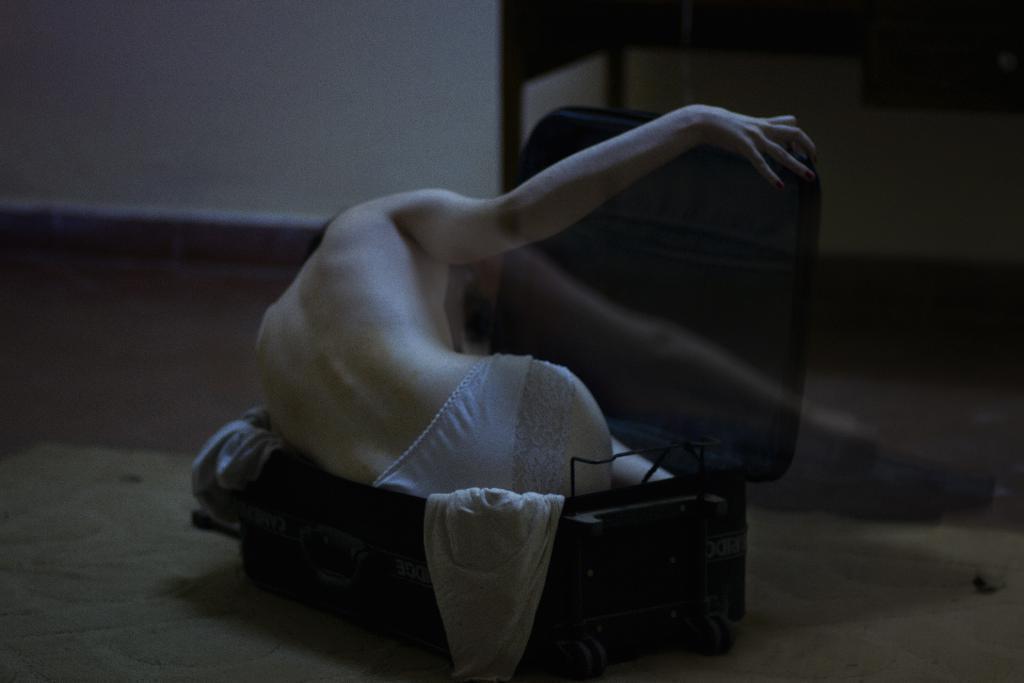How would you summarize this image in a sentence or two? In this image I can see a suitcase and in it I can see few clothes and a person. I can also see this image is little bit in dark and on the top right side of the image I can see a table like thing. 